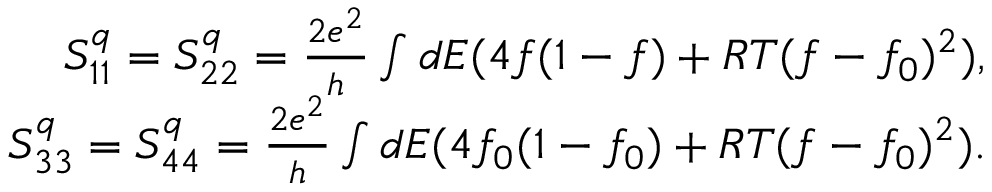<formula> <loc_0><loc_0><loc_500><loc_500>\begin{array} { r } { S _ { 1 1 } ^ { q } = S _ { 2 2 } ^ { q } = \frac { 2 e ^ { 2 } } { h } \int d E ( 4 f ( 1 - f ) + R T ( f - f _ { 0 } ) ^ { 2 } ) , } \\ { S _ { 3 3 } ^ { q } = S _ { 4 4 } ^ { q } = \frac { 2 e ^ { 2 } } { h } \int d E ( 4 f _ { 0 } ( 1 - f _ { 0 } ) + R T ( f - f _ { 0 } ) ^ { 2 } ) . } \end{array}</formula> 